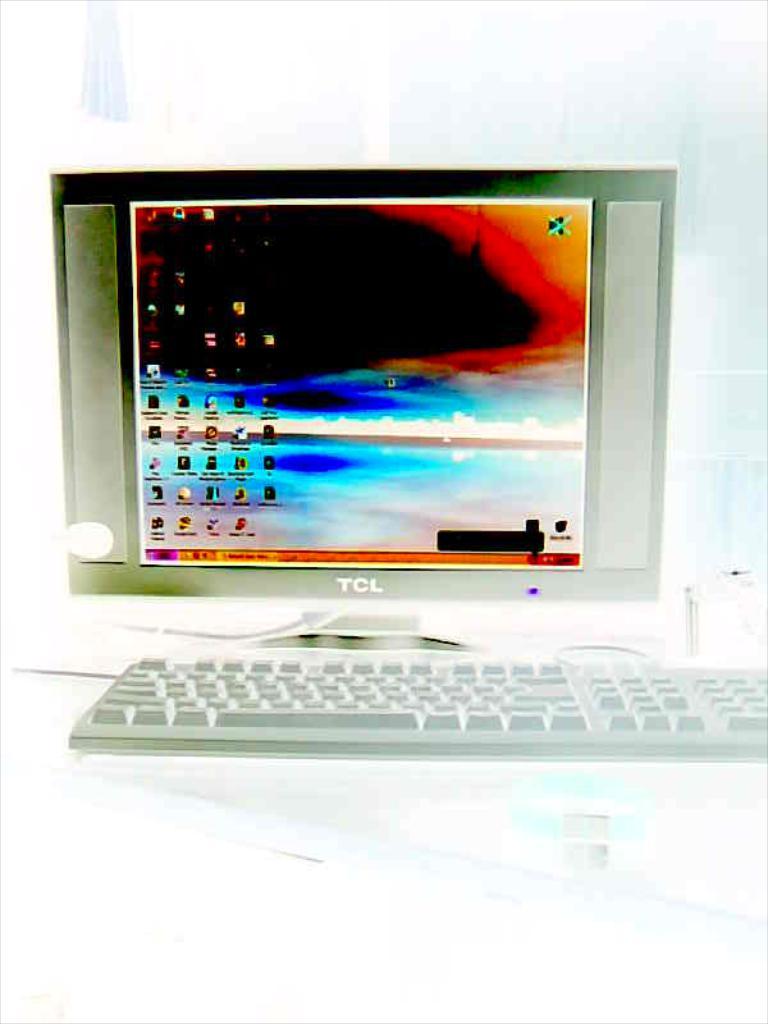What brand is this monitor?
Provide a short and direct response. Tcl. Brand name nokia?
Your answer should be very brief. No. 